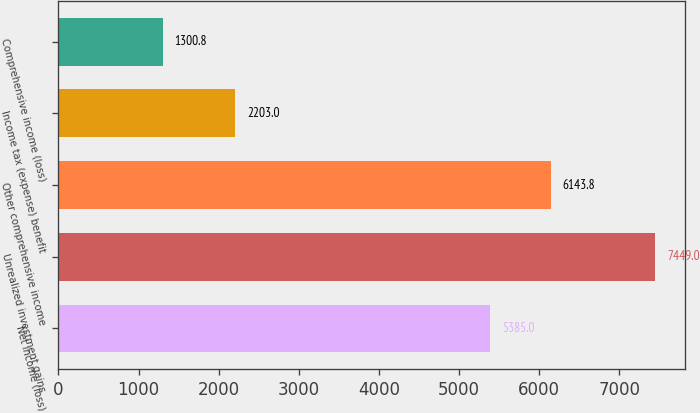Convert chart. <chart><loc_0><loc_0><loc_500><loc_500><bar_chart><fcel>Net income (loss)<fcel>Unrealized investment gains<fcel>Other comprehensive income<fcel>Income tax (expense) benefit<fcel>Comprehensive income (loss)<nl><fcel>5385<fcel>7449<fcel>6143.8<fcel>2203<fcel>1300.8<nl></chart> 